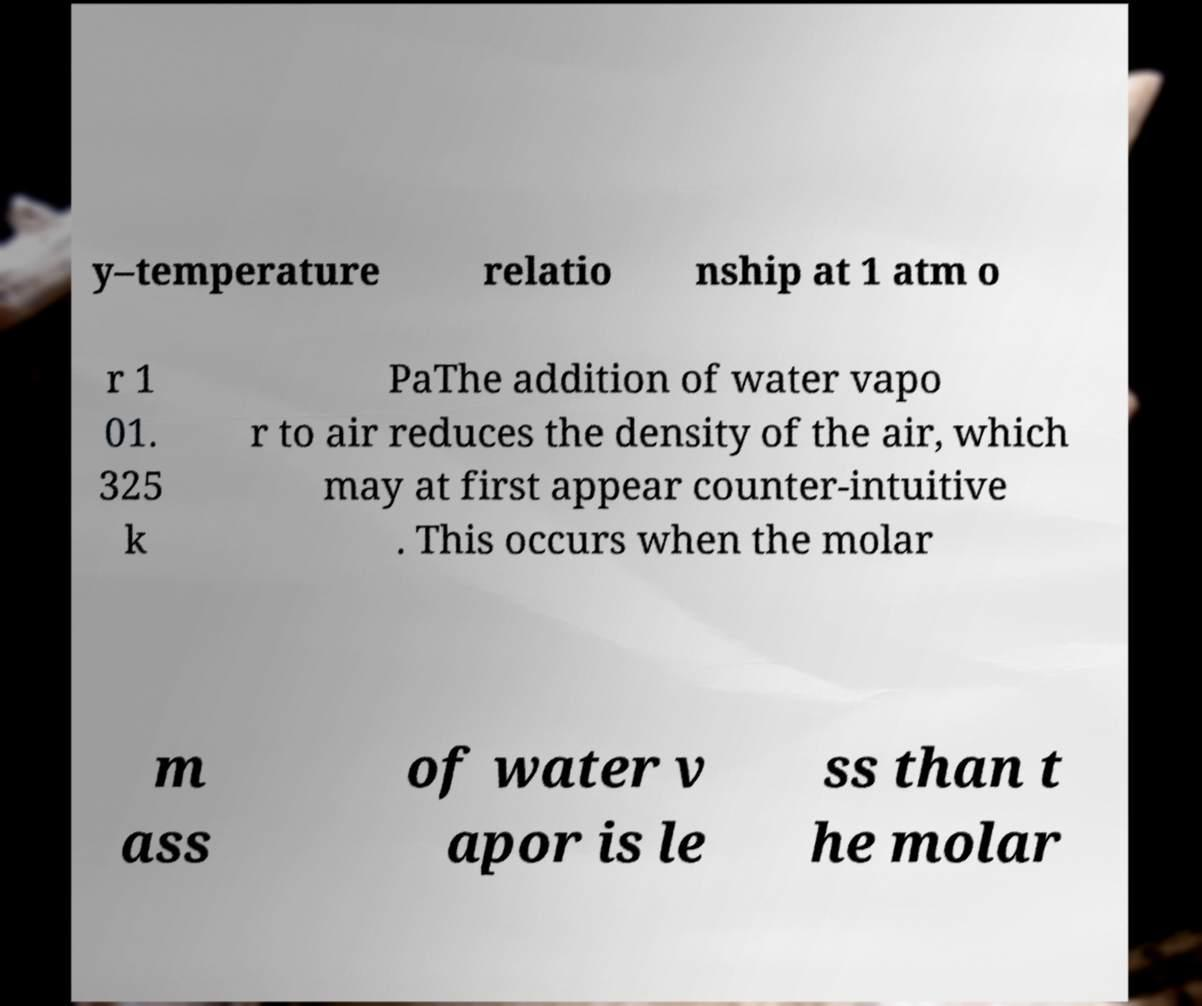Can you accurately transcribe the text from the provided image for me? y–temperature relatio nship at 1 atm o r 1 01. 325 k PaThe addition of water vapo r to air reduces the density of the air, which may at first appear counter-intuitive . This occurs when the molar m ass of water v apor is le ss than t he molar 